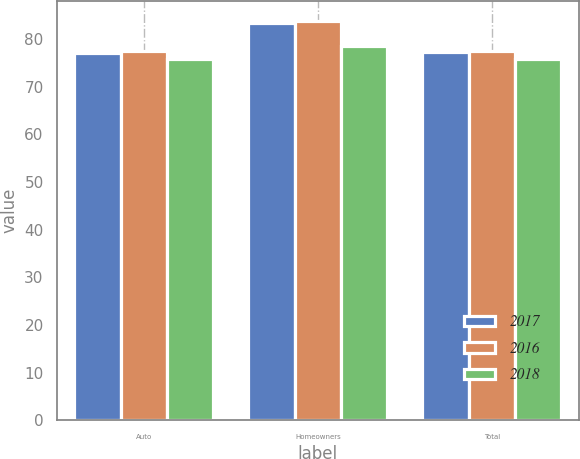<chart> <loc_0><loc_0><loc_500><loc_500><stacked_bar_chart><ecel><fcel>Auto<fcel>Homeowners<fcel>Total<nl><fcel>2017<fcel>77<fcel>83.4<fcel>77.2<nl><fcel>2016<fcel>77.5<fcel>83.8<fcel>77.6<nl><fcel>2018<fcel>75.8<fcel>78.6<fcel>75.8<nl></chart> 